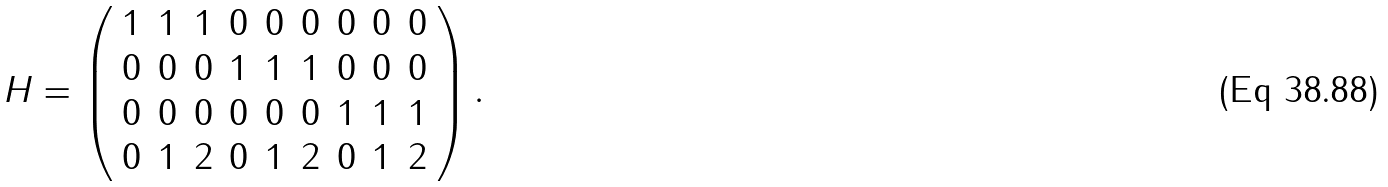<formula> <loc_0><loc_0><loc_500><loc_500>H = \left ( \begin{array} { c c c c c c c c c } 1 & 1 & 1 & 0 & 0 & 0 & 0 & 0 & 0 \\ 0 & 0 & 0 & 1 & 1 & 1 & 0 & 0 & 0 \\ 0 & 0 & 0 & 0 & 0 & 0 & 1 & 1 & 1 \\ 0 & 1 & 2 & 0 & 1 & 2 & 0 & 1 & 2 \end{array} \right ) .</formula> 